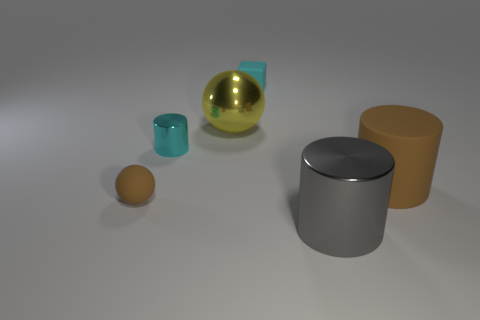Subtract all big cylinders. How many cylinders are left? 1 Add 2 small cyan matte cylinders. How many objects exist? 8 Subtract all spheres. How many objects are left? 4 Add 5 tiny purple matte things. How many tiny purple matte things exist? 5 Subtract 0 gray spheres. How many objects are left? 6 Subtract all yellow metal balls. Subtract all gray shiny things. How many objects are left? 4 Add 1 rubber cylinders. How many rubber cylinders are left? 2 